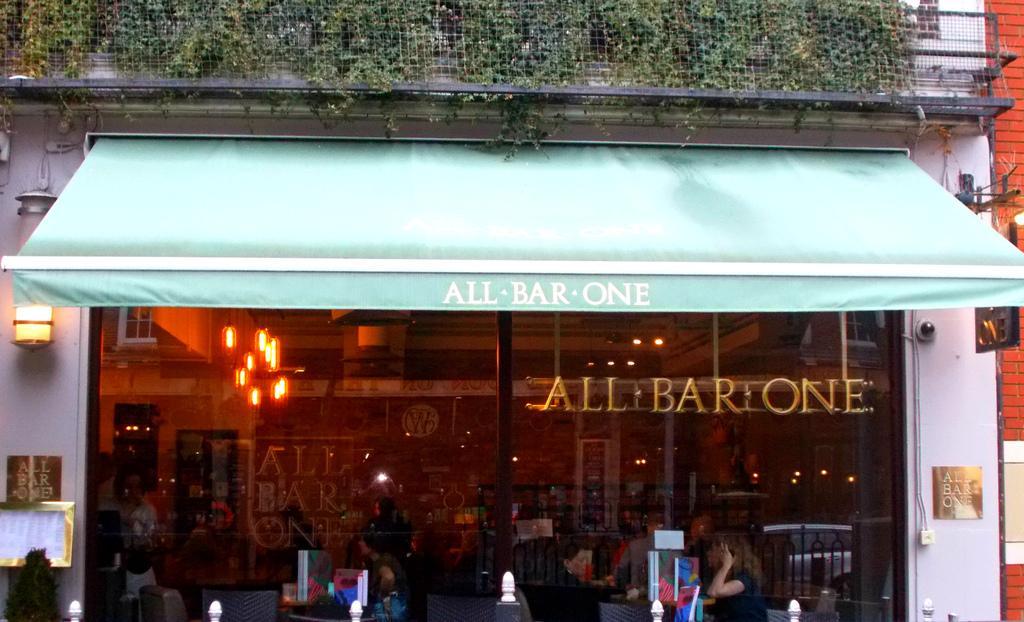Can you describe this image briefly? On the right side, there are persons sitting on a chair, on which there are some objects. On the left side, there is a person sitting on a chair in front of the table, on which there are some objects. Above them, there is a roof, on which there is a white color text. In the background, there is a building having plants on the wall, which is covered with a fence and a golden text on a glass door. Through this glass door, we can see there are lights arranged. 